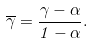<formula> <loc_0><loc_0><loc_500><loc_500>\overline { \gamma } = \frac { \gamma - \alpha } { 1 - \alpha } .</formula> 